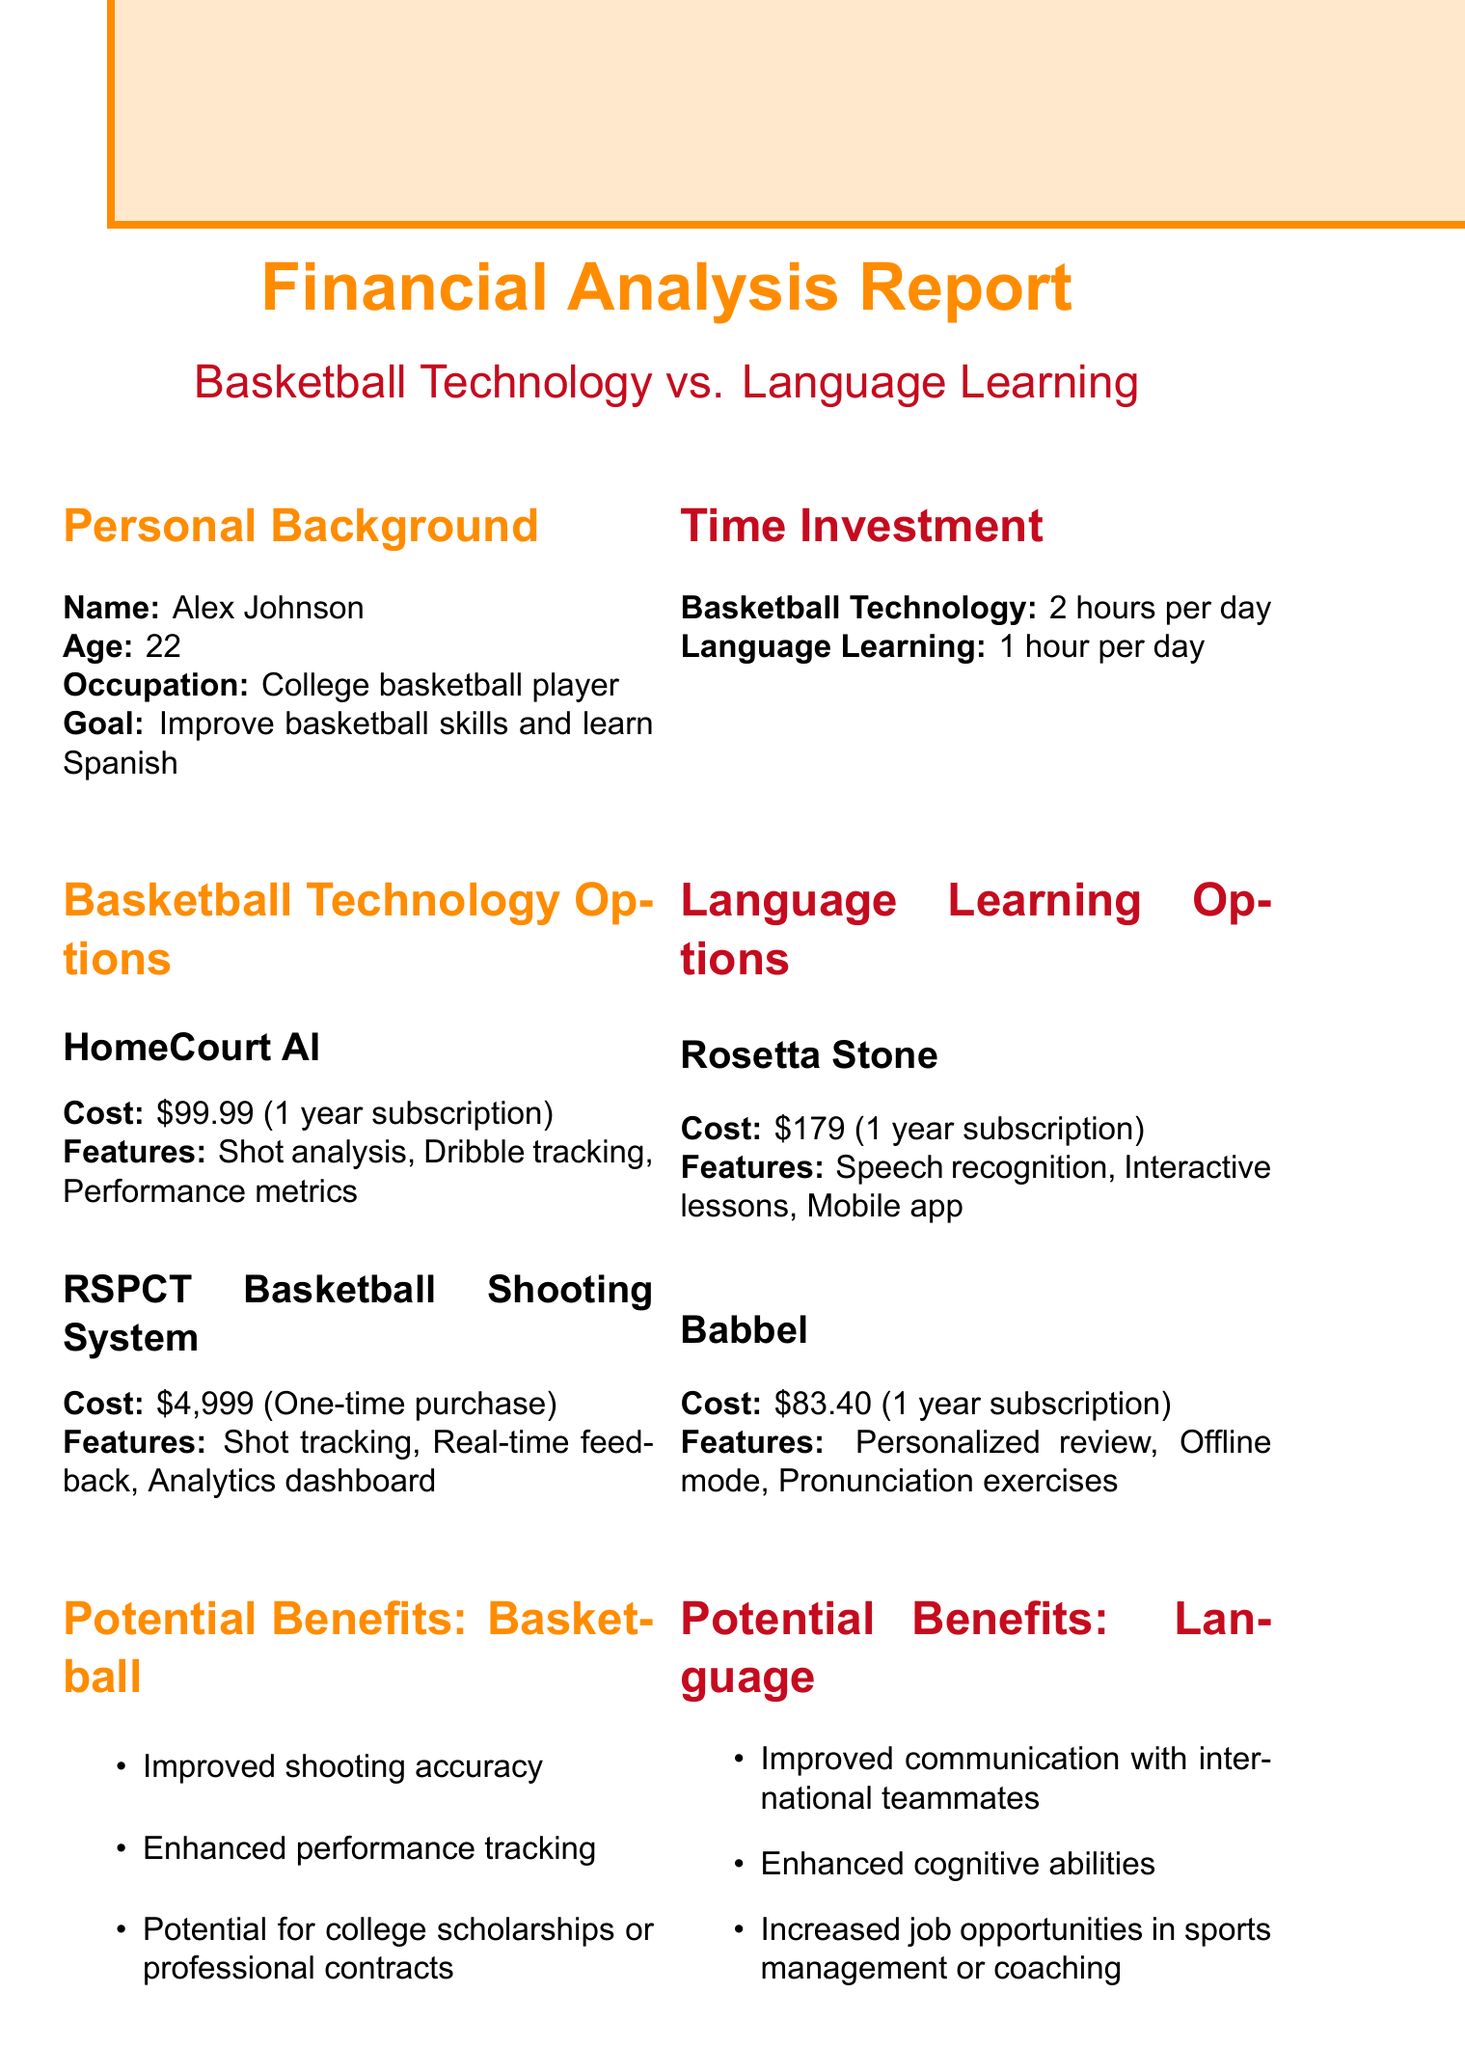what is the cost of HomeCourt AI? The cost of HomeCourt AI is mentioned in the document as $99.99 for a 1 year subscription.
Answer: $99.99 what is the duration of the RSPCT Basketball Shooting System? The document states that the RSPCT Basketball Shooting System is a one-time purchase.
Answer: One-time purchase what are the features of Babbel? Babbel has features listed in the document, which include personalized review, offline mode, and pronunciation exercises.
Answer: Personalized review, offline mode, pronunciation exercises what is the projected short-term outcome for basketball technology? The document indicates that the short-term outcome for basketball technology is a 10% improvement in shooting accuracy.
Answer: 10% improvement in shooting accuracy how many hours are required for language learning each day? The required time investment for language learning as per the document is detailed as 1 hour per day.
Answer: 1 hour per day which option costs the most for basketball technology? According to the document, the RSPCT Basketball Shooting System costs the most among the basketball technology options.
Answer: RSPCT Basketball Shooting System what potential benefit is highlighted for language learning? The document outlines improved communication with international teammates as a potential benefit for language learning.
Answer: Improved communication with international teammates what is the long-term potential increase in salary from language learning? The long-term outcome for language learning states there is a potential $5,000 annual salary increase in future career.
Answer: $5,000 what is the total cost of using Rosetta Stone? The document states that the total cost for Rosetta Stone is $179 for a 1 year subscription.
Answer: $179 